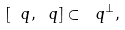<formula> <loc_0><loc_0><loc_500><loc_500>[ \ q , \ q ] \subset \ q ^ { \perp } ,</formula> 